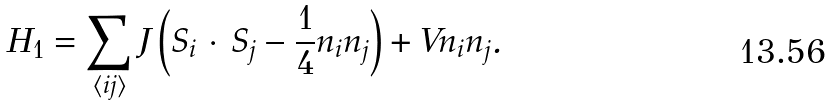<formula> <loc_0><loc_0><loc_500><loc_500>H _ { 1 } = \sum _ { \langle i j \rangle } J \left ( { S } _ { i } \, \cdot \, { S } _ { j } - \frac { 1 } { 4 } n _ { i } n _ { j } \right ) + V n _ { i } n _ { j } .</formula> 